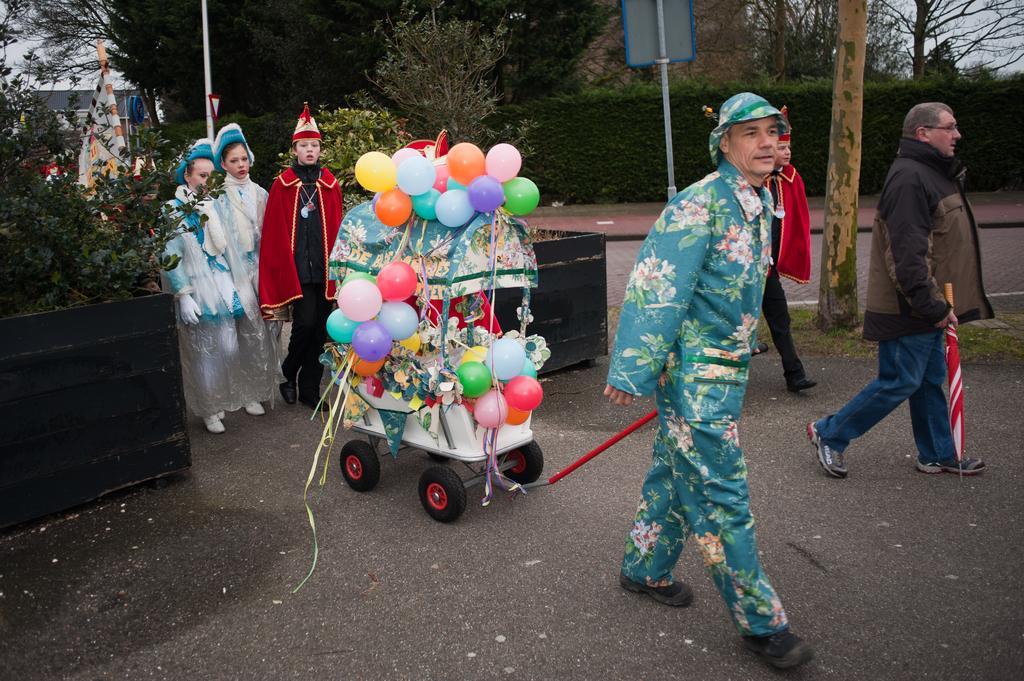How would you summarize this image in a sentence or two? In this image I can see group of people walking and I can also see the stroller decorated with balloons and the balloons are in multi color. In the background I can see few poles, trees and buildings and the sky is in white color. 